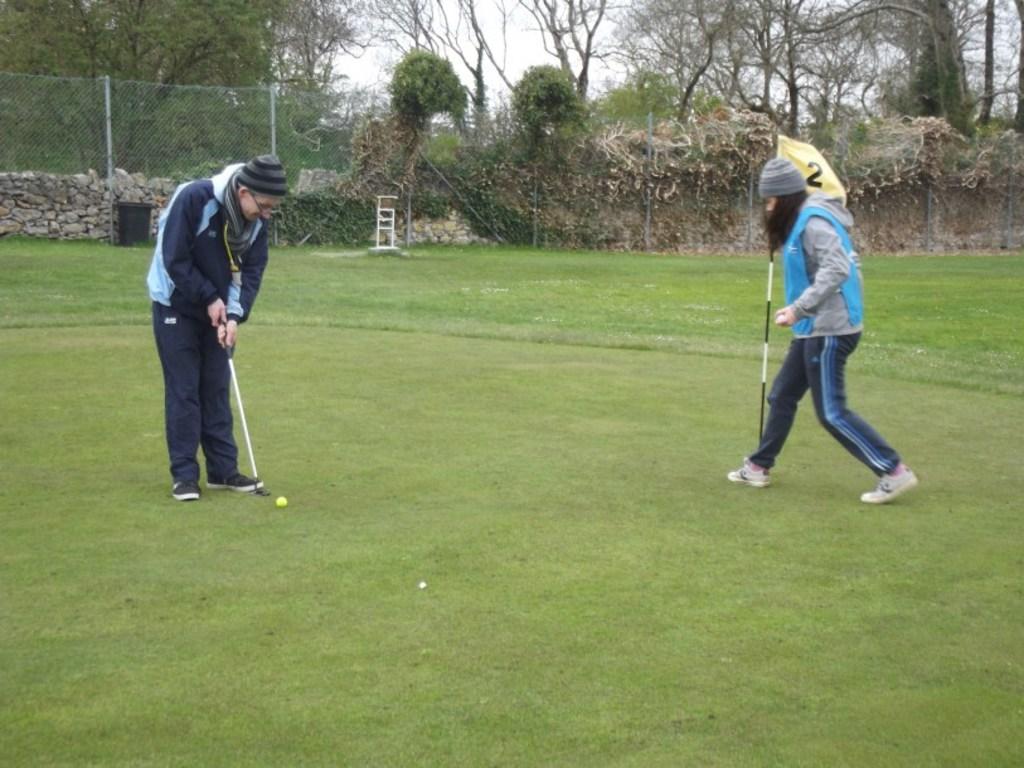Describe this image in one or two sentences. In this image we can see two persons, among them one person is holding a golf stick and the other person is holding the flag, we can see a ball on the ground, there are some trees, poles, fence and the wall, also we can see the sky. 